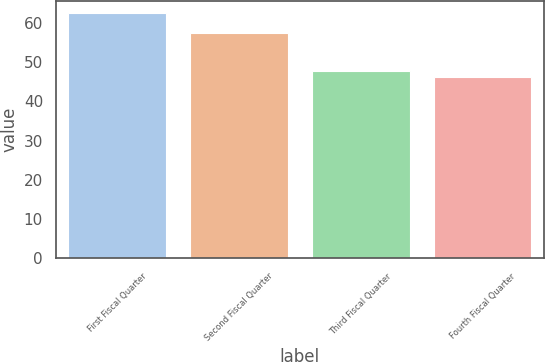<chart> <loc_0><loc_0><loc_500><loc_500><bar_chart><fcel>First Fiscal Quarter<fcel>Second Fiscal Quarter<fcel>Third Fiscal Quarter<fcel>Fourth Fiscal Quarter<nl><fcel>62.46<fcel>57.54<fcel>47.89<fcel>46.27<nl></chart> 